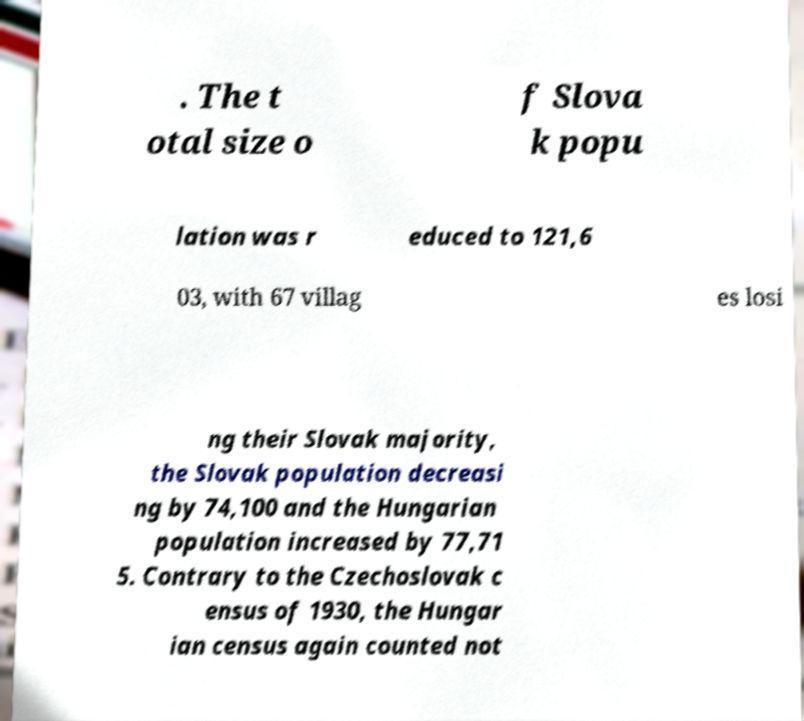Can you accurately transcribe the text from the provided image for me? . The t otal size o f Slova k popu lation was r educed to 121,6 03, with 67 villag es losi ng their Slovak majority, the Slovak population decreasi ng by 74,100 and the Hungarian population increased by 77,71 5. Contrary to the Czechoslovak c ensus of 1930, the Hungar ian census again counted not 